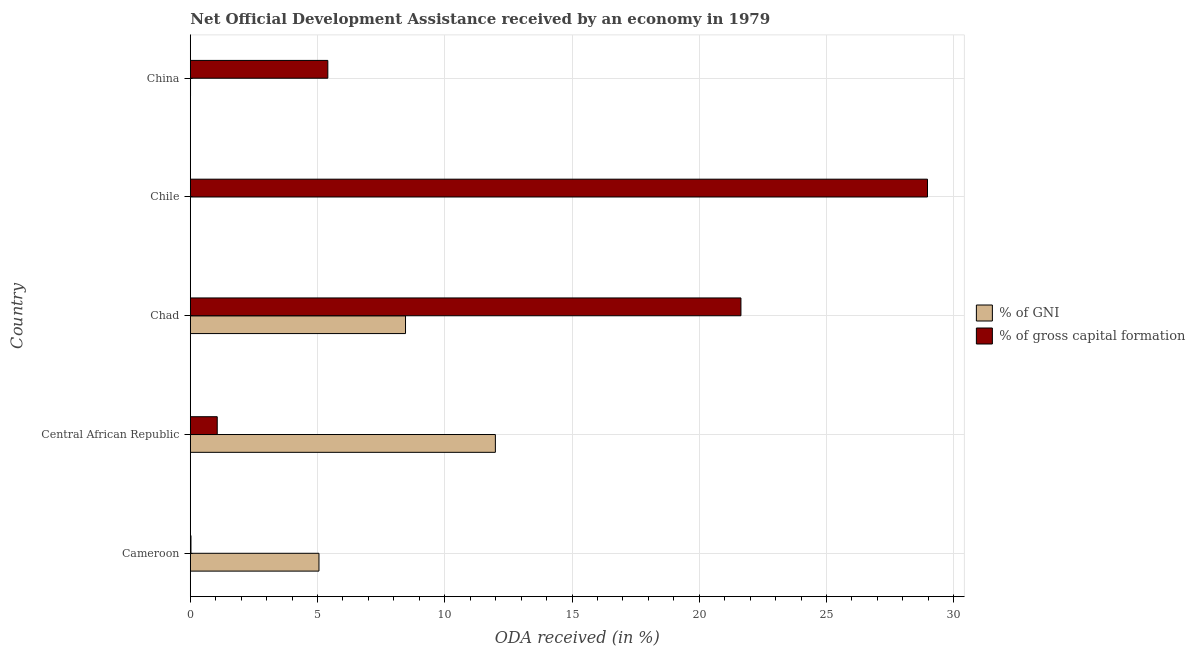Are the number of bars per tick equal to the number of legend labels?
Your response must be concise. No. Are the number of bars on each tick of the Y-axis equal?
Your response must be concise. No. How many bars are there on the 5th tick from the bottom?
Make the answer very short. 2. What is the label of the 5th group of bars from the top?
Offer a very short reply. Cameroon. What is the oda received as percentage of gni in China?
Offer a terse response. 0.01. Across all countries, what is the maximum oda received as percentage of gni?
Keep it short and to the point. 11.99. Across all countries, what is the minimum oda received as percentage of gni?
Your response must be concise. 0. In which country was the oda received as percentage of gross capital formation maximum?
Offer a very short reply. Chile. What is the total oda received as percentage of gni in the graph?
Ensure brevity in your answer.  25.51. What is the difference between the oda received as percentage of gross capital formation in Central African Republic and that in China?
Provide a succinct answer. -4.35. What is the difference between the oda received as percentage of gross capital formation in Chad and the oda received as percentage of gni in Chile?
Your answer should be compact. 21.64. What is the average oda received as percentage of gni per country?
Offer a very short reply. 5.1. What is the difference between the oda received as percentage of gni and oda received as percentage of gross capital formation in Central African Republic?
Make the answer very short. 10.93. What is the ratio of the oda received as percentage of gross capital formation in Cameroon to that in Central African Republic?
Your answer should be compact. 0.03. Is the oda received as percentage of gross capital formation in Central African Republic less than that in China?
Make the answer very short. Yes. Is the difference between the oda received as percentage of gni in Central African Republic and Chad greater than the difference between the oda received as percentage of gross capital formation in Central African Republic and Chad?
Your response must be concise. Yes. What is the difference between the highest and the second highest oda received as percentage of gni?
Your answer should be very brief. 3.53. What is the difference between the highest and the lowest oda received as percentage of gross capital formation?
Your answer should be very brief. 28.94. Is the sum of the oda received as percentage of gross capital formation in Central African Republic and Chile greater than the maximum oda received as percentage of gni across all countries?
Your answer should be very brief. Yes. How many countries are there in the graph?
Offer a very short reply. 5. Are the values on the major ticks of X-axis written in scientific E-notation?
Your answer should be very brief. No. What is the title of the graph?
Offer a terse response. Net Official Development Assistance received by an economy in 1979. What is the label or title of the X-axis?
Your response must be concise. ODA received (in %). What is the label or title of the Y-axis?
Make the answer very short. Country. What is the ODA received (in %) of % of GNI in Cameroon?
Your answer should be compact. 5.06. What is the ODA received (in %) in % of gross capital formation in Cameroon?
Keep it short and to the point. 0.03. What is the ODA received (in %) of % of GNI in Central African Republic?
Ensure brevity in your answer.  11.99. What is the ODA received (in %) of % of gross capital formation in Central African Republic?
Offer a very short reply. 1.06. What is the ODA received (in %) in % of GNI in Chad?
Ensure brevity in your answer.  8.46. What is the ODA received (in %) in % of gross capital formation in Chad?
Make the answer very short. 21.64. What is the ODA received (in %) of % of gross capital formation in Chile?
Give a very brief answer. 28.97. What is the ODA received (in %) of % of GNI in China?
Make the answer very short. 0.01. What is the ODA received (in %) of % of gross capital formation in China?
Your response must be concise. 5.4. Across all countries, what is the maximum ODA received (in %) of % of GNI?
Your answer should be very brief. 11.99. Across all countries, what is the maximum ODA received (in %) in % of gross capital formation?
Offer a terse response. 28.97. Across all countries, what is the minimum ODA received (in %) in % of gross capital formation?
Your answer should be very brief. 0.03. What is the total ODA received (in %) in % of GNI in the graph?
Your response must be concise. 25.51. What is the total ODA received (in %) in % of gross capital formation in the graph?
Ensure brevity in your answer.  57.09. What is the difference between the ODA received (in %) in % of GNI in Cameroon and that in Central African Republic?
Ensure brevity in your answer.  -6.93. What is the difference between the ODA received (in %) in % of gross capital formation in Cameroon and that in Central African Republic?
Ensure brevity in your answer.  -1.03. What is the difference between the ODA received (in %) in % of GNI in Cameroon and that in Chad?
Your response must be concise. -3.4. What is the difference between the ODA received (in %) in % of gross capital formation in Cameroon and that in Chad?
Your response must be concise. -21.61. What is the difference between the ODA received (in %) in % of gross capital formation in Cameroon and that in Chile?
Your answer should be compact. -28.94. What is the difference between the ODA received (in %) in % of GNI in Cameroon and that in China?
Your response must be concise. 5.05. What is the difference between the ODA received (in %) of % of gross capital formation in Cameroon and that in China?
Provide a short and direct response. -5.38. What is the difference between the ODA received (in %) in % of GNI in Central African Republic and that in Chad?
Keep it short and to the point. 3.53. What is the difference between the ODA received (in %) of % of gross capital formation in Central African Republic and that in Chad?
Your response must be concise. -20.58. What is the difference between the ODA received (in %) of % of gross capital formation in Central African Republic and that in Chile?
Your response must be concise. -27.91. What is the difference between the ODA received (in %) of % of GNI in Central African Republic and that in China?
Ensure brevity in your answer.  11.98. What is the difference between the ODA received (in %) in % of gross capital formation in Central African Republic and that in China?
Make the answer very short. -4.35. What is the difference between the ODA received (in %) of % of gross capital formation in Chad and that in Chile?
Provide a succinct answer. -7.33. What is the difference between the ODA received (in %) of % of GNI in Chad and that in China?
Ensure brevity in your answer.  8.45. What is the difference between the ODA received (in %) of % of gross capital formation in Chad and that in China?
Provide a short and direct response. 16.23. What is the difference between the ODA received (in %) of % of gross capital formation in Chile and that in China?
Your answer should be very brief. 23.56. What is the difference between the ODA received (in %) of % of GNI in Cameroon and the ODA received (in %) of % of gross capital formation in Central African Republic?
Provide a succinct answer. 4. What is the difference between the ODA received (in %) in % of GNI in Cameroon and the ODA received (in %) in % of gross capital formation in Chad?
Your response must be concise. -16.58. What is the difference between the ODA received (in %) of % of GNI in Cameroon and the ODA received (in %) of % of gross capital formation in Chile?
Make the answer very short. -23.91. What is the difference between the ODA received (in %) in % of GNI in Cameroon and the ODA received (in %) in % of gross capital formation in China?
Offer a terse response. -0.35. What is the difference between the ODA received (in %) of % of GNI in Central African Republic and the ODA received (in %) of % of gross capital formation in Chad?
Keep it short and to the point. -9.65. What is the difference between the ODA received (in %) of % of GNI in Central African Republic and the ODA received (in %) of % of gross capital formation in Chile?
Keep it short and to the point. -16.98. What is the difference between the ODA received (in %) in % of GNI in Central African Republic and the ODA received (in %) in % of gross capital formation in China?
Offer a very short reply. 6.58. What is the difference between the ODA received (in %) of % of GNI in Chad and the ODA received (in %) of % of gross capital formation in Chile?
Give a very brief answer. -20.51. What is the difference between the ODA received (in %) in % of GNI in Chad and the ODA received (in %) in % of gross capital formation in China?
Provide a short and direct response. 3.05. What is the average ODA received (in %) in % of GNI per country?
Provide a short and direct response. 5.1. What is the average ODA received (in %) of % of gross capital formation per country?
Provide a succinct answer. 11.42. What is the difference between the ODA received (in %) in % of GNI and ODA received (in %) in % of gross capital formation in Cameroon?
Keep it short and to the point. 5.03. What is the difference between the ODA received (in %) in % of GNI and ODA received (in %) in % of gross capital formation in Central African Republic?
Offer a very short reply. 10.93. What is the difference between the ODA received (in %) of % of GNI and ODA received (in %) of % of gross capital formation in Chad?
Your answer should be compact. -13.18. What is the difference between the ODA received (in %) of % of GNI and ODA received (in %) of % of gross capital formation in China?
Provide a short and direct response. -5.39. What is the ratio of the ODA received (in %) in % of GNI in Cameroon to that in Central African Republic?
Your answer should be compact. 0.42. What is the ratio of the ODA received (in %) of % of gross capital formation in Cameroon to that in Central African Republic?
Provide a short and direct response. 0.02. What is the ratio of the ODA received (in %) in % of GNI in Cameroon to that in Chad?
Ensure brevity in your answer.  0.6. What is the ratio of the ODA received (in %) in % of gross capital formation in Cameroon to that in Chad?
Provide a succinct answer. 0. What is the ratio of the ODA received (in %) of % of gross capital formation in Cameroon to that in Chile?
Your response must be concise. 0. What is the ratio of the ODA received (in %) in % of GNI in Cameroon to that in China?
Your answer should be very brief. 530.67. What is the ratio of the ODA received (in %) of % of gross capital formation in Cameroon to that in China?
Ensure brevity in your answer.  0. What is the ratio of the ODA received (in %) of % of GNI in Central African Republic to that in Chad?
Keep it short and to the point. 1.42. What is the ratio of the ODA received (in %) of % of gross capital formation in Central African Republic to that in Chad?
Your response must be concise. 0.05. What is the ratio of the ODA received (in %) of % of gross capital formation in Central African Republic to that in Chile?
Provide a short and direct response. 0.04. What is the ratio of the ODA received (in %) of % of GNI in Central African Republic to that in China?
Provide a short and direct response. 1258.25. What is the ratio of the ODA received (in %) of % of gross capital formation in Central African Republic to that in China?
Ensure brevity in your answer.  0.2. What is the ratio of the ODA received (in %) in % of gross capital formation in Chad to that in Chile?
Provide a succinct answer. 0.75. What is the ratio of the ODA received (in %) in % of GNI in Chad to that in China?
Make the answer very short. 887.6. What is the ratio of the ODA received (in %) in % of gross capital formation in Chad to that in China?
Your answer should be very brief. 4. What is the ratio of the ODA received (in %) in % of gross capital formation in Chile to that in China?
Offer a very short reply. 5.36. What is the difference between the highest and the second highest ODA received (in %) of % of GNI?
Ensure brevity in your answer.  3.53. What is the difference between the highest and the second highest ODA received (in %) in % of gross capital formation?
Keep it short and to the point. 7.33. What is the difference between the highest and the lowest ODA received (in %) of % of GNI?
Offer a very short reply. 11.99. What is the difference between the highest and the lowest ODA received (in %) in % of gross capital formation?
Ensure brevity in your answer.  28.94. 